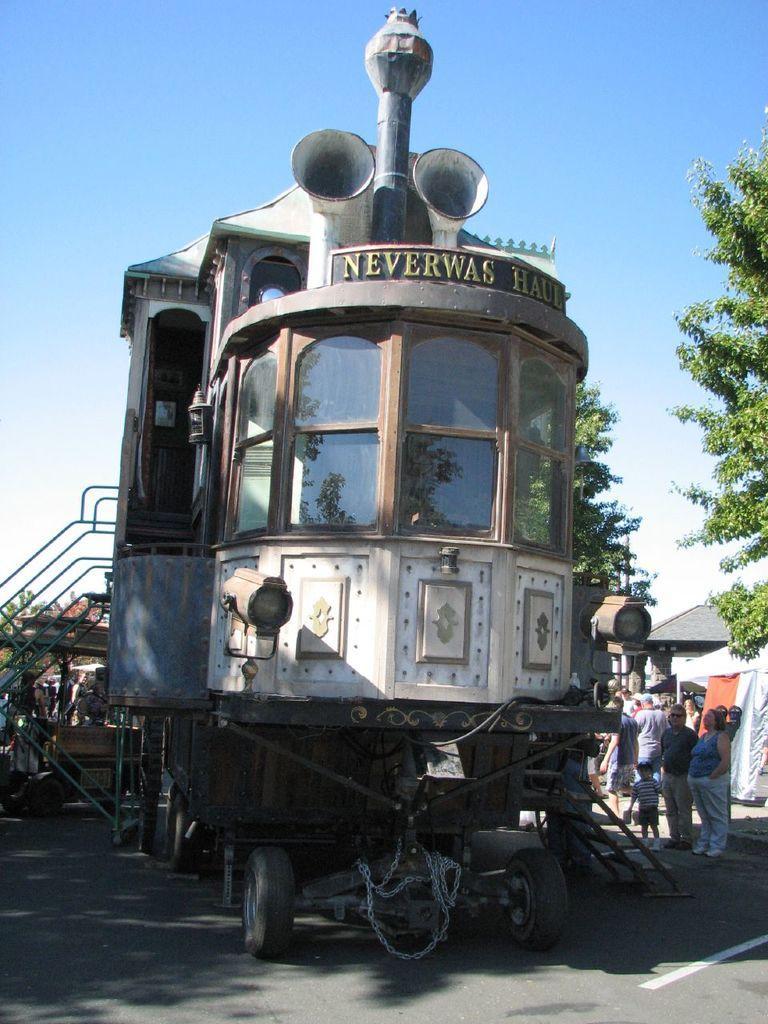Please provide a concise description of this image. In this picture I can see there is a train and it has few stairs at left side, there are a few people standing on the right side and there is a building, trees and the sky are clear. 